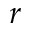<formula> <loc_0><loc_0><loc_500><loc_500>r</formula> 